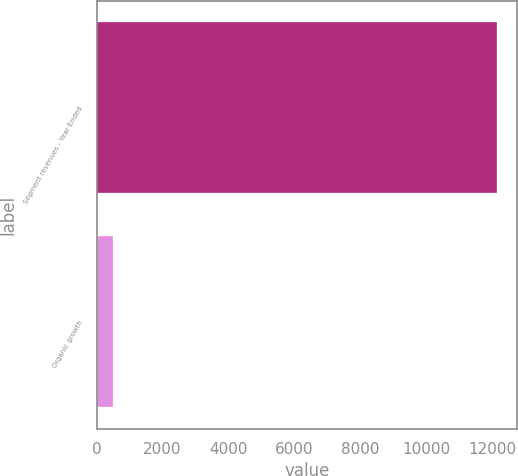Convert chart. <chart><loc_0><loc_0><loc_500><loc_500><bar_chart><fcel>Segment revenues - Year Ended<fcel>Organic growth<nl><fcel>12158.3<fcel>489.3<nl></chart> 